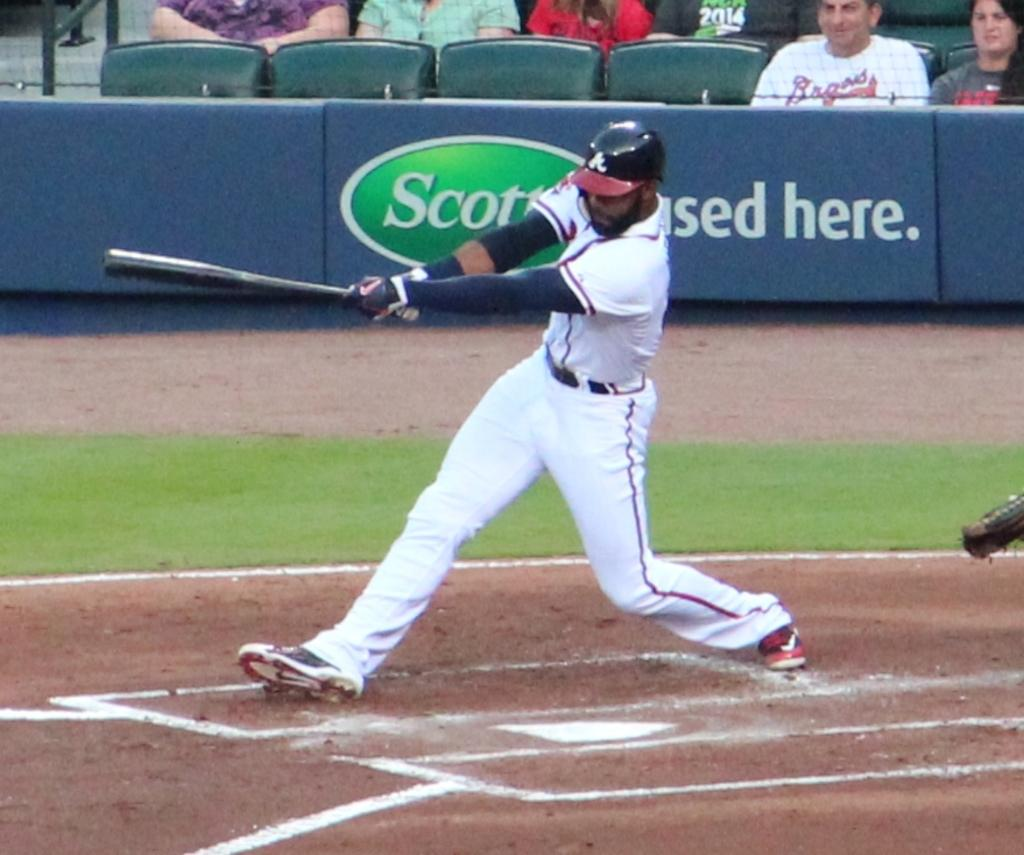<image>
Provide a brief description of the given image. The Braves baseball player swung his bat on a field that has a Scott sign on the wall. 